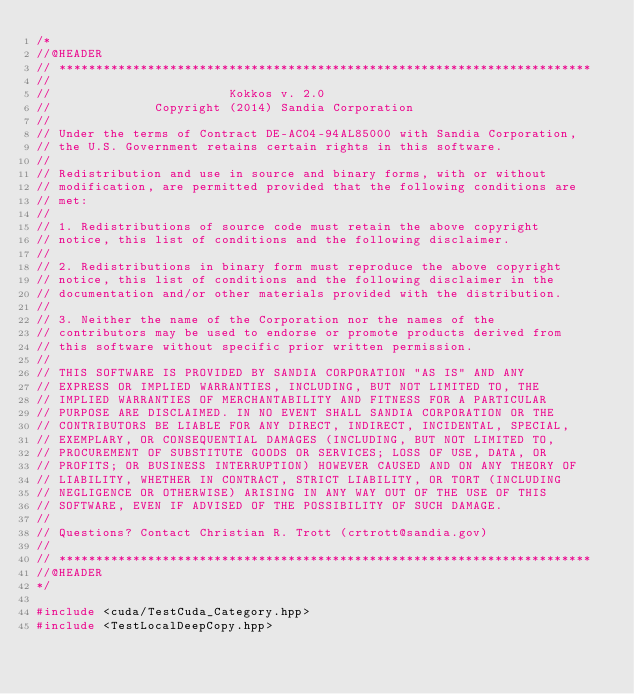<code> <loc_0><loc_0><loc_500><loc_500><_C++_>/*
//@HEADER
// ************************************************************************
//
//                        Kokkos v. 2.0
//              Copyright (2014) Sandia Corporation
//
// Under the terms of Contract DE-AC04-94AL85000 with Sandia Corporation,
// the U.S. Government retains certain rights in this software.
//
// Redistribution and use in source and binary forms, with or without
// modification, are permitted provided that the following conditions are
// met:
//
// 1. Redistributions of source code must retain the above copyright
// notice, this list of conditions and the following disclaimer.
//
// 2. Redistributions in binary form must reproduce the above copyright
// notice, this list of conditions and the following disclaimer in the
// documentation and/or other materials provided with the distribution.
//
// 3. Neither the name of the Corporation nor the names of the
// contributors may be used to endorse or promote products derived from
// this software without specific prior written permission.
//
// THIS SOFTWARE IS PROVIDED BY SANDIA CORPORATION "AS IS" AND ANY
// EXPRESS OR IMPLIED WARRANTIES, INCLUDING, BUT NOT LIMITED TO, THE
// IMPLIED WARRANTIES OF MERCHANTABILITY AND FITNESS FOR A PARTICULAR
// PURPOSE ARE DISCLAIMED. IN NO EVENT SHALL SANDIA CORPORATION OR THE
// CONTRIBUTORS BE LIABLE FOR ANY DIRECT, INDIRECT, INCIDENTAL, SPECIAL,
// EXEMPLARY, OR CONSEQUENTIAL DAMAGES (INCLUDING, BUT NOT LIMITED TO,
// PROCUREMENT OF SUBSTITUTE GOODS OR SERVICES; LOSS OF USE, DATA, OR
// PROFITS; OR BUSINESS INTERRUPTION) HOWEVER CAUSED AND ON ANY THEORY OF
// LIABILITY, WHETHER IN CONTRACT, STRICT LIABILITY, OR TORT (INCLUDING
// NEGLIGENCE OR OTHERWISE) ARISING IN ANY WAY OUT OF THE USE OF THIS
// SOFTWARE, EVEN IF ADVISED OF THE POSSIBILITY OF SUCH DAMAGE.
//
// Questions? Contact Christian R. Trott (crtrott@sandia.gov)
//
// ************************************************************************
//@HEADER
*/

#include <cuda/TestCuda_Category.hpp>
#include <TestLocalDeepCopy.hpp>

</code> 